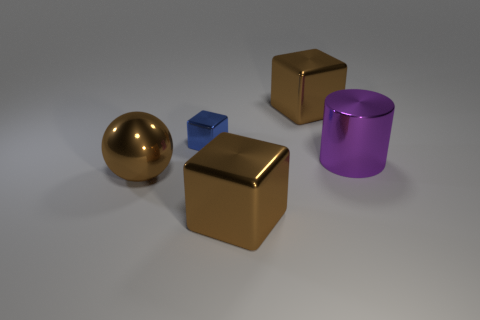Are the cube in front of the big purple shiny cylinder and the brown object behind the purple cylinder made of the same material?
Keep it short and to the point. Yes. Are there the same number of tiny blue metal cubes right of the tiny metal object and blue objects left of the large brown metallic sphere?
Your answer should be compact. Yes. What number of big gray balls are the same material as the tiny blue block?
Give a very brief answer. 0. What is the size of the brown block that is on the right side of the large brown shiny block that is in front of the large purple thing?
Provide a succinct answer. Large. There is a big brown metal object that is on the left side of the small blue block; does it have the same shape as the thing that is in front of the brown metallic sphere?
Make the answer very short. No. Are there an equal number of brown cubes that are to the left of the small blue metal object and purple objects?
Your answer should be compact. No. What number of big things are brown blocks or brown spheres?
Keep it short and to the point. 3. The brown metal ball has what size?
Provide a short and direct response. Large. There is a blue shiny thing; does it have the same size as the brown metal cube that is in front of the large cylinder?
Your answer should be compact. No. How many yellow things are either spheres or metallic cubes?
Give a very brief answer. 0. 